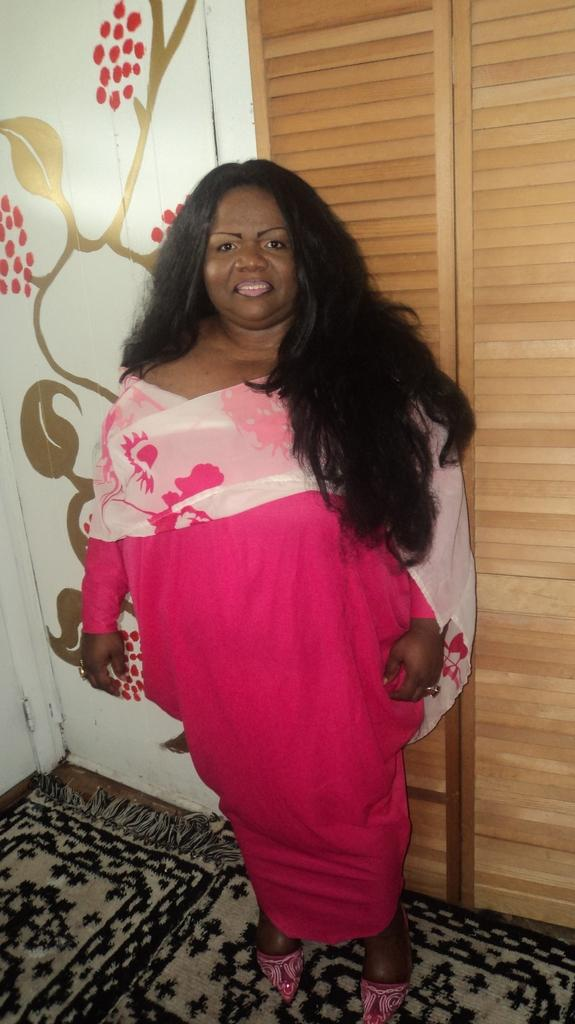What is the main subject in the image? There is a woman standing in the image. What is the woman standing on? The woman is standing on the floor. What is visible behind the woman? There is a wall visible behind the woman. What type of furniture can be seen in the image? There is a closet in the image. What type of health advice is the woman giving in the image? There is no indication in the image that the woman is giving any health advice. What type of shirt is the woman wearing in the image? The image does not provide enough detail to determine the type of shirt the woman is wearing. 